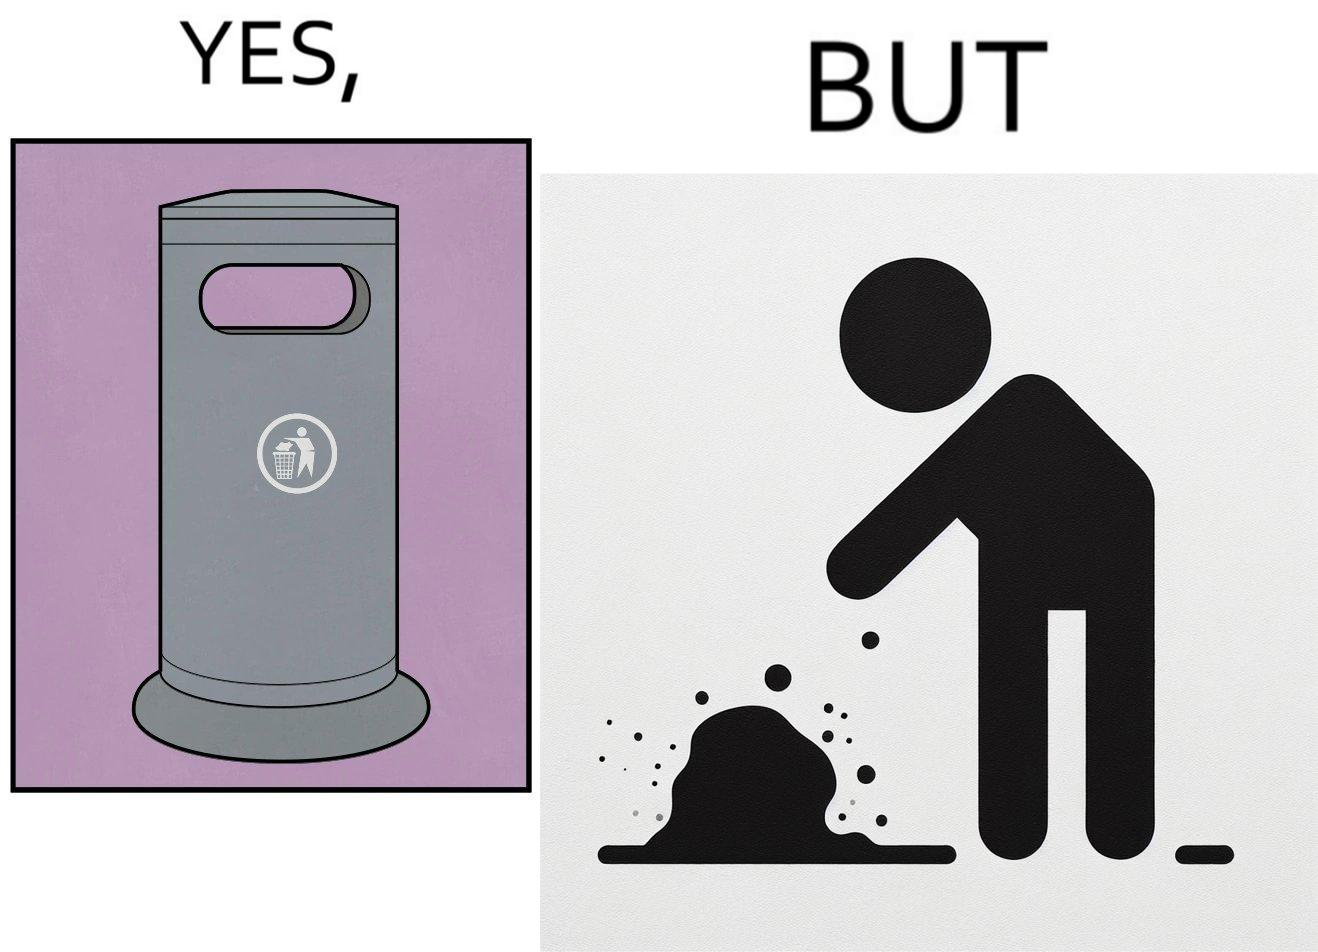Describe the satirical element in this image. The images are ironic because even though garbage bins are provided for humans to dispose waste, by habit humans still choose to make surroundings dirty by disposing garbage improperly 